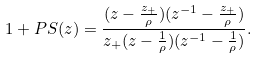Convert formula to latex. <formula><loc_0><loc_0><loc_500><loc_500>1 + P S ( z ) = \frac { ( z - \frac { z _ { + } } { \rho } ) ( z ^ { - 1 } - \frac { z _ { + } } { \rho } ) } { z _ { + } ( z - \frac { 1 } { \rho } ) ( z ^ { - 1 } - \frac { 1 } { \rho } ) } .</formula> 